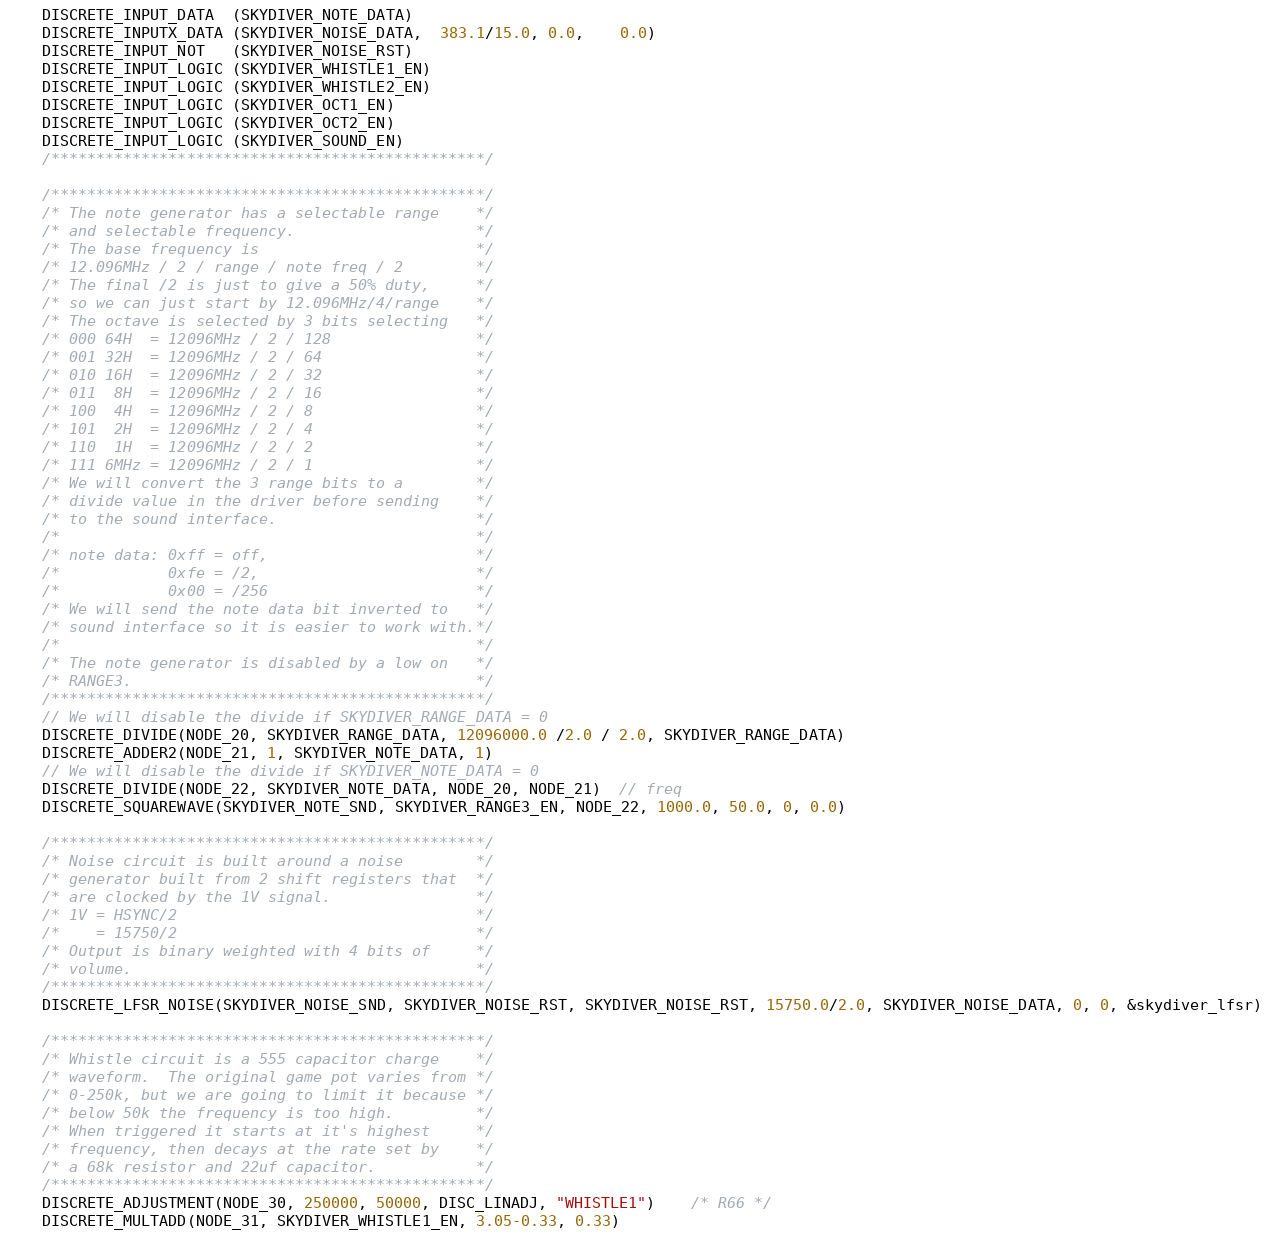<code> <loc_0><loc_0><loc_500><loc_500><_C++_>	DISCRETE_INPUT_DATA  (SKYDIVER_NOTE_DATA)
	DISCRETE_INPUTX_DATA (SKYDIVER_NOISE_DATA,  383.1/15.0, 0.0,    0.0)
	DISCRETE_INPUT_NOT   (SKYDIVER_NOISE_RST)
	DISCRETE_INPUT_LOGIC (SKYDIVER_WHISTLE1_EN)
	DISCRETE_INPUT_LOGIC (SKYDIVER_WHISTLE2_EN)
	DISCRETE_INPUT_LOGIC (SKYDIVER_OCT1_EN)
	DISCRETE_INPUT_LOGIC (SKYDIVER_OCT2_EN)
	DISCRETE_INPUT_LOGIC (SKYDIVER_SOUND_EN)
	/************************************************/

	/************************************************/
	/* The note generator has a selectable range    */
	/* and selectable frequency.                    */
	/* The base frequency is                        */
	/* 12.096MHz / 2 / range / note freq / 2        */
	/* The final /2 is just to give a 50% duty,     */
	/* so we can just start by 12.096MHz/4/range    */
	/* The octave is selected by 3 bits selecting   */
	/* 000 64H  = 12096MHz / 2 / 128                */
	/* 001 32H  = 12096MHz / 2 / 64                 */
	/* 010 16H  = 12096MHz / 2 / 32                 */
	/* 011  8H  = 12096MHz / 2 / 16                 */
	/* 100  4H  = 12096MHz / 2 / 8                  */
	/* 101  2H  = 12096MHz / 2 / 4                  */
	/* 110  1H  = 12096MHz / 2 / 2                  */
	/* 111 6MHz = 12096MHz / 2 / 1                  */
	/* We will convert the 3 range bits to a        */
	/* divide value in the driver before sending    */
	/* to the sound interface.                      */
	/*                                              */
	/* note data: 0xff = off,                       */
	/*            0xfe = /2,                        */
	/*            0x00 = /256                       */
	/* We will send the note data bit inverted to   */
	/* sound interface so it is easier to work with.*/
	/*                                              */
	/* The note generator is disabled by a low on   */
	/* RANGE3.                                      */
	/************************************************/
	// We will disable the divide if SKYDIVER_RANGE_DATA = 0
	DISCRETE_DIVIDE(NODE_20, SKYDIVER_RANGE_DATA, 12096000.0 /2.0 / 2.0, SKYDIVER_RANGE_DATA)
	DISCRETE_ADDER2(NODE_21, 1, SKYDIVER_NOTE_DATA, 1)
	// We will disable the divide if SKYDIVER_NOTE_DATA = 0
	DISCRETE_DIVIDE(NODE_22, SKYDIVER_NOTE_DATA, NODE_20, NODE_21)  // freq
	DISCRETE_SQUAREWAVE(SKYDIVER_NOTE_SND, SKYDIVER_RANGE3_EN, NODE_22, 1000.0, 50.0, 0, 0.0)

	/************************************************/
	/* Noise circuit is built around a noise        */
	/* generator built from 2 shift registers that  */
	/* are clocked by the 1V signal.                */
	/* 1V = HSYNC/2                                 */
	/*    = 15750/2                                 */
	/* Output is binary weighted with 4 bits of     */
	/* volume.                                      */
	/************************************************/
	DISCRETE_LFSR_NOISE(SKYDIVER_NOISE_SND, SKYDIVER_NOISE_RST, SKYDIVER_NOISE_RST, 15750.0/2.0, SKYDIVER_NOISE_DATA, 0, 0, &skydiver_lfsr)

	/************************************************/
	/* Whistle circuit is a 555 capacitor charge    */
	/* waveform.  The original game pot varies from */
	/* 0-250k, but we are going to limit it because */
	/* below 50k the frequency is too high.         */
	/* When triggered it starts at it's highest     */
	/* frequency, then decays at the rate set by    */
	/* a 68k resistor and 22uf capacitor.           */
	/************************************************/
	DISCRETE_ADJUSTMENT(NODE_30, 250000, 50000, DISC_LINADJ, "WHISTLE1")    /* R66 */
	DISCRETE_MULTADD(NODE_31, SKYDIVER_WHISTLE1_EN, 3.05-0.33, 0.33)</code> 